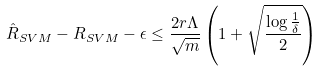Convert formula to latex. <formula><loc_0><loc_0><loc_500><loc_500>\hat { R } _ { S V M } - R _ { S V M } - \epsilon \leq \frac { 2 r \Lambda } { \sqrt { m } } \left ( 1 + \sqrt { \frac { \log \frac { 1 } { \delta } } { 2 } } \right )</formula> 